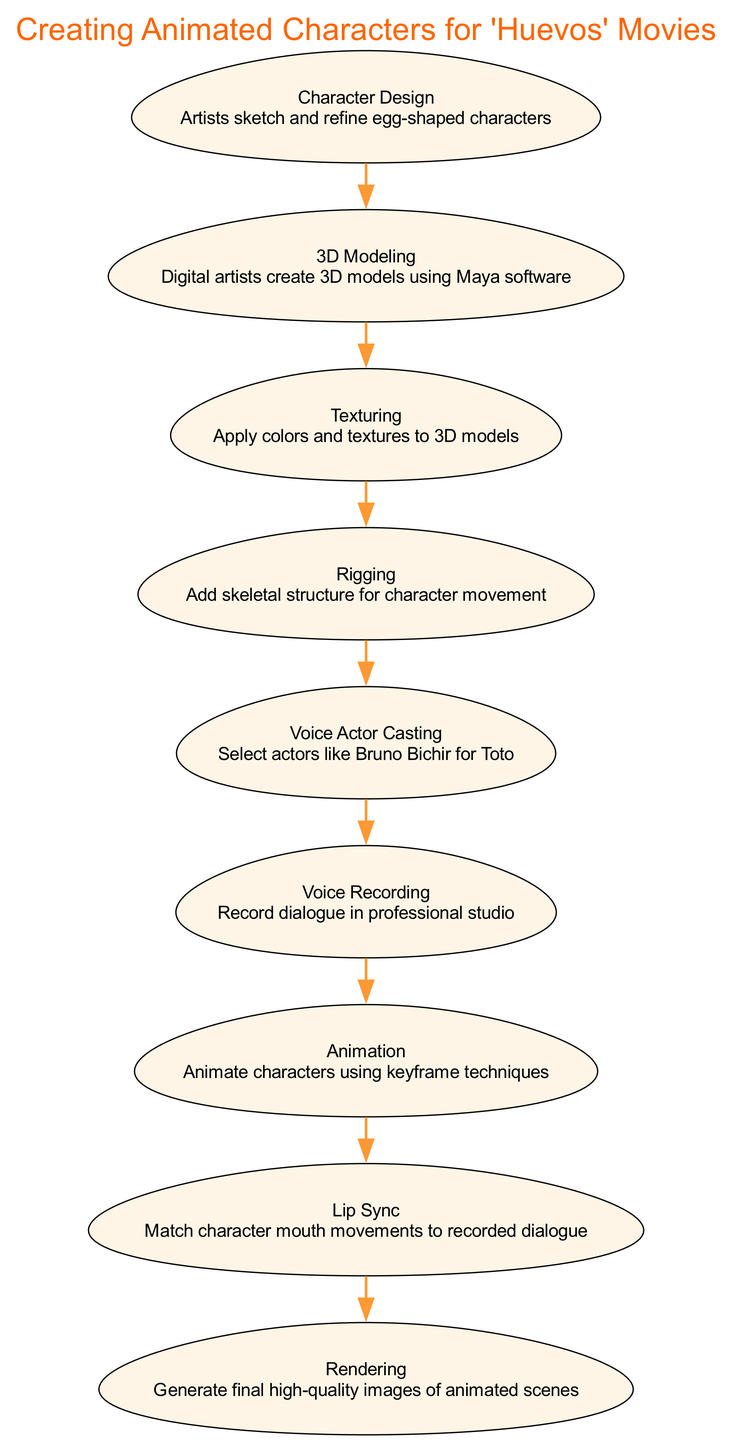What is the first step in the character creation process? The diagram specifies that the first step is "Character Design," where artists sketch and refine egg-shaped characters.
Answer: Character Design How many steps are there in the entire process? The diagram lists a total of nine steps involved in creating animated characters for the "Huevos" movies.
Answer: 9 What is the primary software used in the 3D Modeling step? The diagram identifies that "Maya software" is the primary tool used by digital artists during the 3D Modeling process.
Answer: Maya software Which step involves matching mouth movements to recorded dialogue? According to the diagram, the step that involves this task is called "Lip Sync."
Answer: Lip Sync What comes directly after Voice Actor Casting in the sequence? The diagram shows that "Voice Recording" is the step that follows "Voice Actor Casting."
Answer: Voice Recording Which step applies colors and textures to models? The diagram specifies that the "Texturing" step is responsible for applying colors and textures to the 3D models.
Answer: Texturing How are the animated characters created in the rearrangement of steps? The diagram shows that characters are not directly created but go through a sequence starting from design and leading to rendering; thus, the logical flow can be seen step by step through the provided nodes.
Answer: 3D Modeling → Texturing → Rigging → Animation → Lip Sync → Rendering Who provides the voice for the character Toto? The diagram mentions that "Bruno Bichir" is the selected voice actor for the character Toto in the "Voice Actor Casting" step.
Answer: Bruno Bichir What is required in the Rigging step? The diagram states that the Rigging step involves adding a skeletal structure for character movement, crucial for animating the characters effectively.
Answer: Skeletal structure 